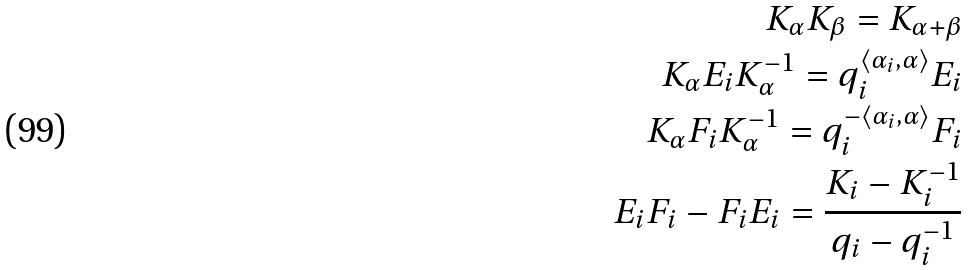Convert formula to latex. <formula><loc_0><loc_0><loc_500><loc_500>K _ { \alpha } K _ { \beta } = K _ { \alpha + \beta } \\ K _ { \alpha } E _ { i } K _ { \alpha } ^ { - 1 } = q _ { i } ^ { \langle \alpha _ { i } , \alpha \rangle } E _ { i } \\ K _ { \alpha } F _ { i } K _ { \alpha } ^ { - 1 } = q _ { i } ^ { - \langle \alpha _ { i } , \alpha \rangle } F _ { i } \\ E _ { i } F _ { i } - F _ { i } E _ { i } = \frac { K _ { i } - K _ { i } ^ { - 1 } } { q _ { i } - q _ { i } ^ { - 1 } }</formula> 